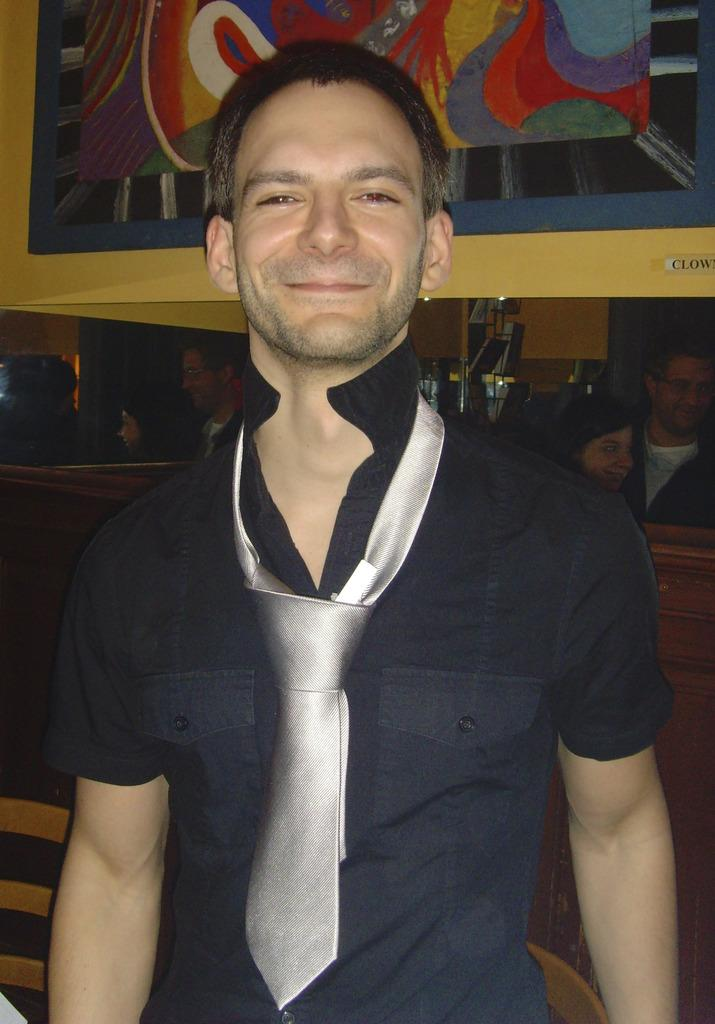How many people are in the image? There are people in the image, but the exact number is not specified. Can you describe the attire of one of the people? One person is wearing a tie. What can be seen on the wall in the image? There is a painting on the wall in the image. Are there any fairies visible in the image? There is no mention of fairies in the image, so we cannot confirm their presence. Is there a spy in the image? There is no indication of a spy in the image based on the provided facts. 